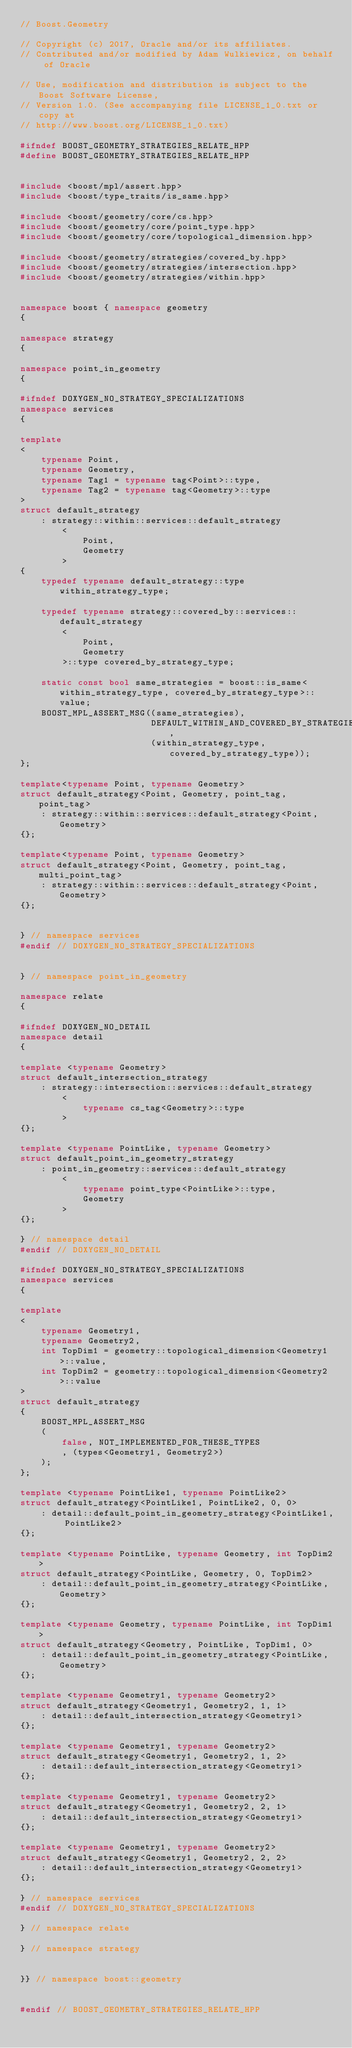<code> <loc_0><loc_0><loc_500><loc_500><_C++_>// Boost.Geometry

// Copyright (c) 2017, Oracle and/or its affiliates.
// Contributed and/or modified by Adam Wulkiewicz, on behalf of Oracle

// Use, modification and distribution is subject to the Boost Software License,
// Version 1.0. (See accompanying file LICENSE_1_0.txt or copy at
// http://www.boost.org/LICENSE_1_0.txt)

#ifndef BOOST_GEOMETRY_STRATEGIES_RELATE_HPP
#define BOOST_GEOMETRY_STRATEGIES_RELATE_HPP


#include <boost/mpl/assert.hpp>
#include <boost/type_traits/is_same.hpp>

#include <boost/geometry/core/cs.hpp>
#include <boost/geometry/core/point_type.hpp>
#include <boost/geometry/core/topological_dimension.hpp>

#include <boost/geometry/strategies/covered_by.hpp>
#include <boost/geometry/strategies/intersection.hpp>
#include <boost/geometry/strategies/within.hpp>


namespace boost { namespace geometry
{

namespace strategy
{
    
namespace point_in_geometry
{

#ifndef DOXYGEN_NO_STRATEGY_SPECIALIZATIONS
namespace services
{

template
<
    typename Point,
    typename Geometry,
    typename Tag1 = typename tag<Point>::type,
    typename Tag2 = typename tag<Geometry>::type
>
struct default_strategy
    : strategy::within::services::default_strategy
        <
            Point,
            Geometry
        >
{
    typedef typename default_strategy::type within_strategy_type;

    typedef typename strategy::covered_by::services::default_strategy
        <
            Point,
            Geometry
        >::type covered_by_strategy_type;

    static const bool same_strategies = boost::is_same<within_strategy_type, covered_by_strategy_type>::value;
    BOOST_MPL_ASSERT_MSG((same_strategies),
                         DEFAULT_WITHIN_AND_COVERED_BY_STRATEGIES_NOT_COMPATIBLE,
                         (within_strategy_type, covered_by_strategy_type));
};

template<typename Point, typename Geometry>
struct default_strategy<Point, Geometry, point_tag, point_tag>
    : strategy::within::services::default_strategy<Point, Geometry>
{};

template<typename Point, typename Geometry>
struct default_strategy<Point, Geometry, point_tag, multi_point_tag>
    : strategy::within::services::default_strategy<Point, Geometry>
{};


} // namespace services
#endif // DOXYGEN_NO_STRATEGY_SPECIALIZATIONS


} // namespace point_in_geometry

namespace relate
{

#ifndef DOXYGEN_NO_DETAIL
namespace detail
{

template <typename Geometry>
struct default_intersection_strategy
    : strategy::intersection::services::default_strategy
        <
            typename cs_tag<Geometry>::type
        >
{};

template <typename PointLike, typename Geometry>
struct default_point_in_geometry_strategy
    : point_in_geometry::services::default_strategy
        <
            typename point_type<PointLike>::type,
            Geometry
        >
{};

} // namespace detail
#endif // DOXYGEN_NO_DETAIL

#ifndef DOXYGEN_NO_STRATEGY_SPECIALIZATIONS
namespace services
{

template
<
    typename Geometry1,
    typename Geometry2,
    int TopDim1 = geometry::topological_dimension<Geometry1>::value,
    int TopDim2 = geometry::topological_dimension<Geometry2>::value
>
struct default_strategy
{
    BOOST_MPL_ASSERT_MSG
    (
        false, NOT_IMPLEMENTED_FOR_THESE_TYPES
        , (types<Geometry1, Geometry2>)
    );
};

template <typename PointLike1, typename PointLike2>
struct default_strategy<PointLike1, PointLike2, 0, 0>
    : detail::default_point_in_geometry_strategy<PointLike1, PointLike2>
{};

template <typename PointLike, typename Geometry, int TopDim2>
struct default_strategy<PointLike, Geometry, 0, TopDim2>
    : detail::default_point_in_geometry_strategy<PointLike, Geometry>
{};

template <typename Geometry, typename PointLike, int TopDim1>
struct default_strategy<Geometry, PointLike, TopDim1, 0>
    : detail::default_point_in_geometry_strategy<PointLike, Geometry>
{};

template <typename Geometry1, typename Geometry2>
struct default_strategy<Geometry1, Geometry2, 1, 1>
    : detail::default_intersection_strategy<Geometry1>
{};

template <typename Geometry1, typename Geometry2>
struct default_strategy<Geometry1, Geometry2, 1, 2>
    : detail::default_intersection_strategy<Geometry1>
{};

template <typename Geometry1, typename Geometry2>
struct default_strategy<Geometry1, Geometry2, 2, 1>
    : detail::default_intersection_strategy<Geometry1>
{};

template <typename Geometry1, typename Geometry2>
struct default_strategy<Geometry1, Geometry2, 2, 2>
    : detail::default_intersection_strategy<Geometry1>
{};

} // namespace services
#endif // DOXYGEN_NO_STRATEGY_SPECIALIZATIONS

} // namespace relate

} // namespace strategy


}} // namespace boost::geometry


#endif // BOOST_GEOMETRY_STRATEGIES_RELATE_HPP
</code> 